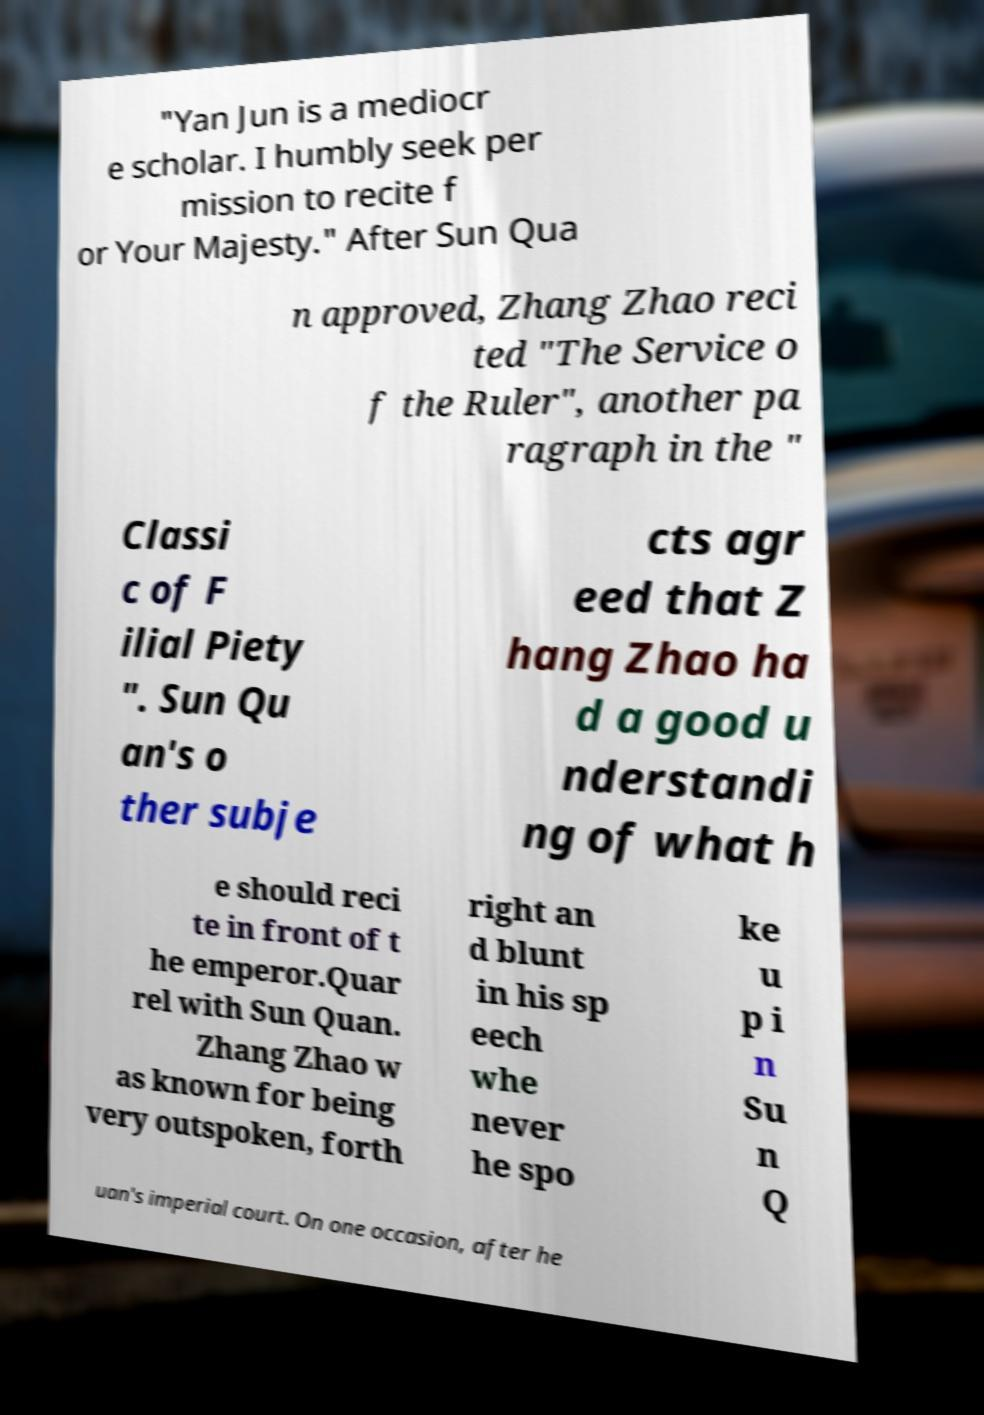Could you assist in decoding the text presented in this image and type it out clearly? "Yan Jun is a mediocr e scholar. I humbly seek per mission to recite f or Your Majesty." After Sun Qua n approved, Zhang Zhao reci ted "The Service o f the Ruler", another pa ragraph in the " Classi c of F ilial Piety ". Sun Qu an's o ther subje cts agr eed that Z hang Zhao ha d a good u nderstandi ng of what h e should reci te in front of t he emperor.Quar rel with Sun Quan. Zhang Zhao w as known for being very outspoken, forth right an d blunt in his sp eech whe never he spo ke u p i n Su n Q uan's imperial court. On one occasion, after he 